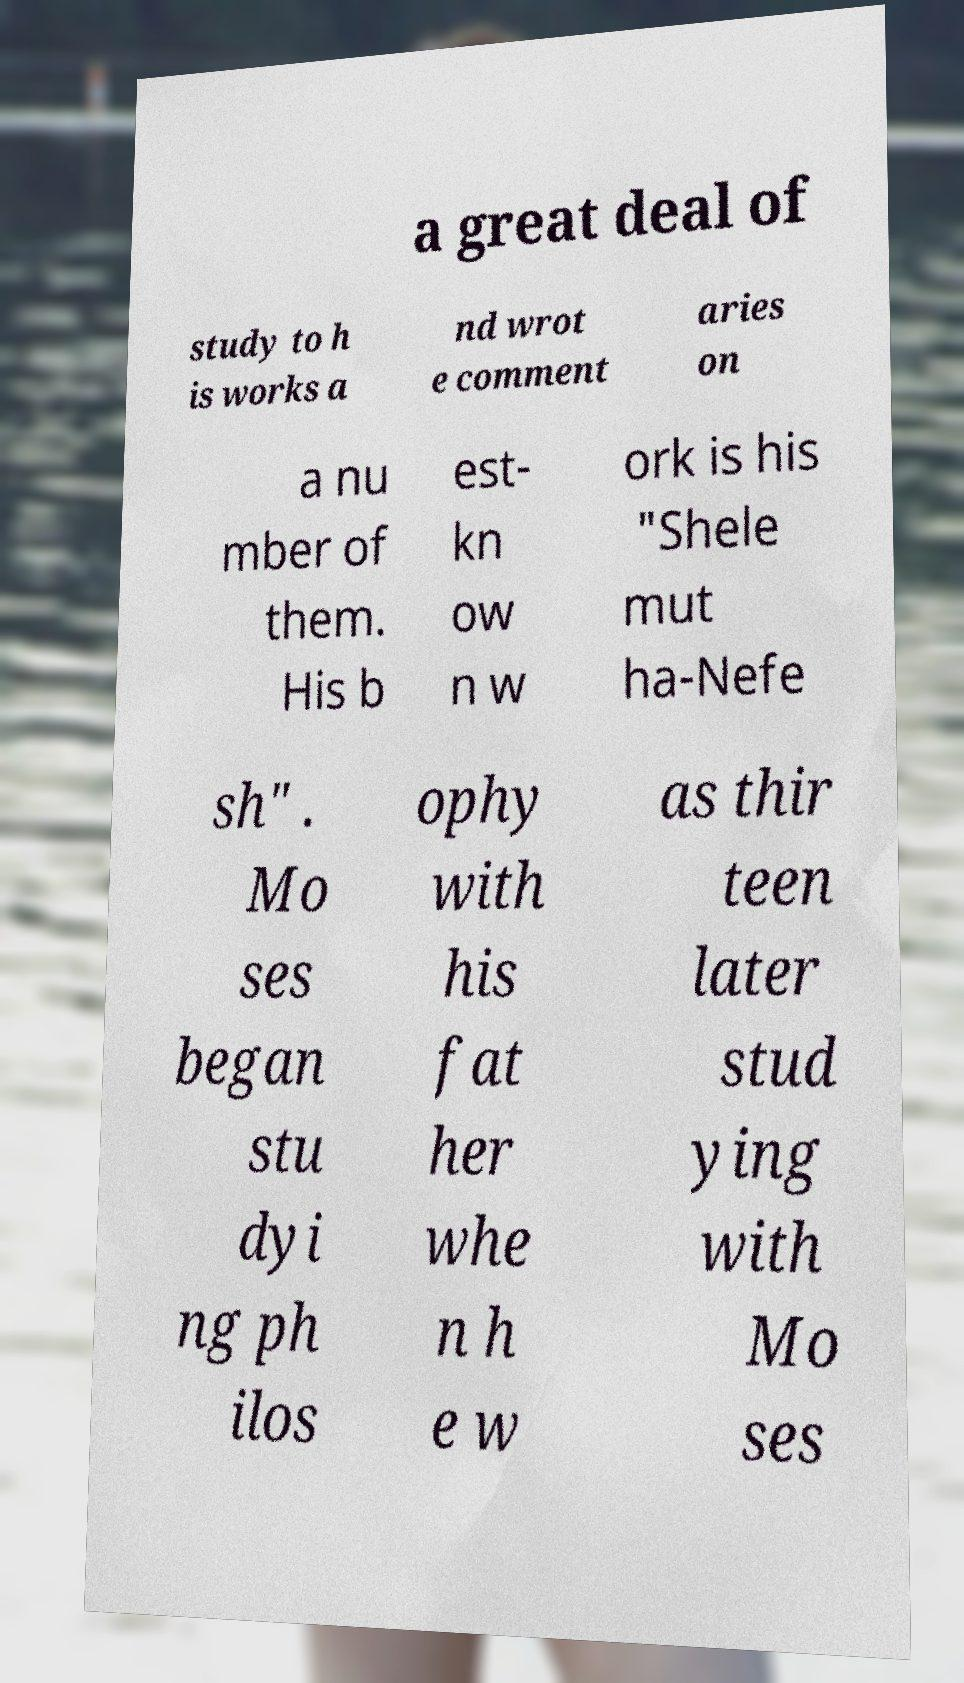There's text embedded in this image that I need extracted. Can you transcribe it verbatim? a great deal of study to h is works a nd wrot e comment aries on a nu mber of them. His b est- kn ow n w ork is his "Shele mut ha-Nefe sh" . Mo ses began stu dyi ng ph ilos ophy with his fat her whe n h e w as thir teen later stud ying with Mo ses 